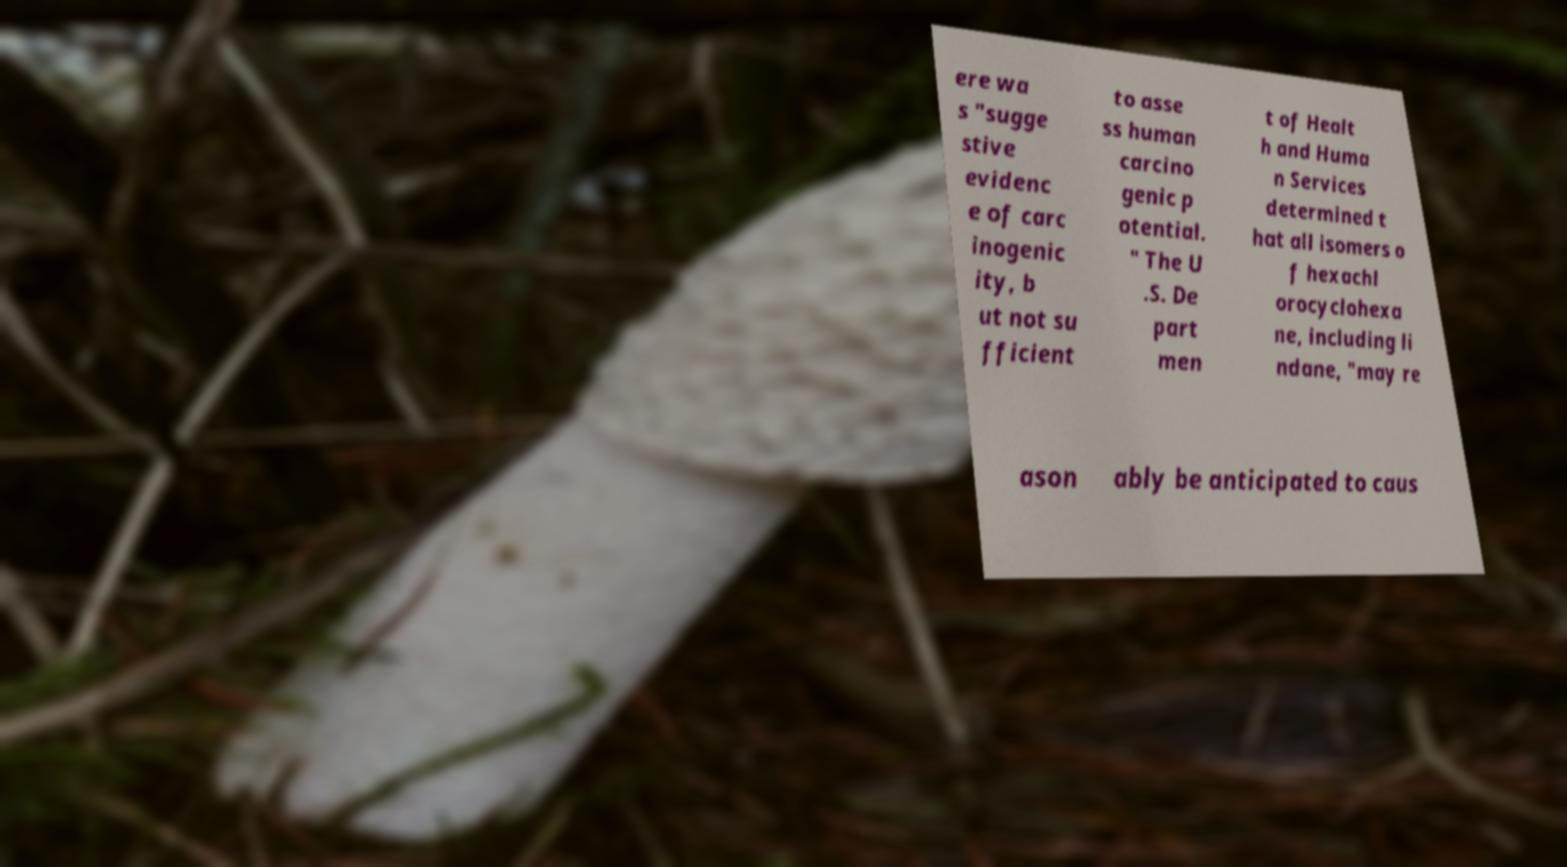Could you extract and type out the text from this image? ere wa s "sugge stive evidenc e of carc inogenic ity, b ut not su fficient to asse ss human carcino genic p otential. " The U .S. De part men t of Healt h and Huma n Services determined t hat all isomers o f hexachl orocyclohexa ne, including li ndane, "may re ason ably be anticipated to caus 